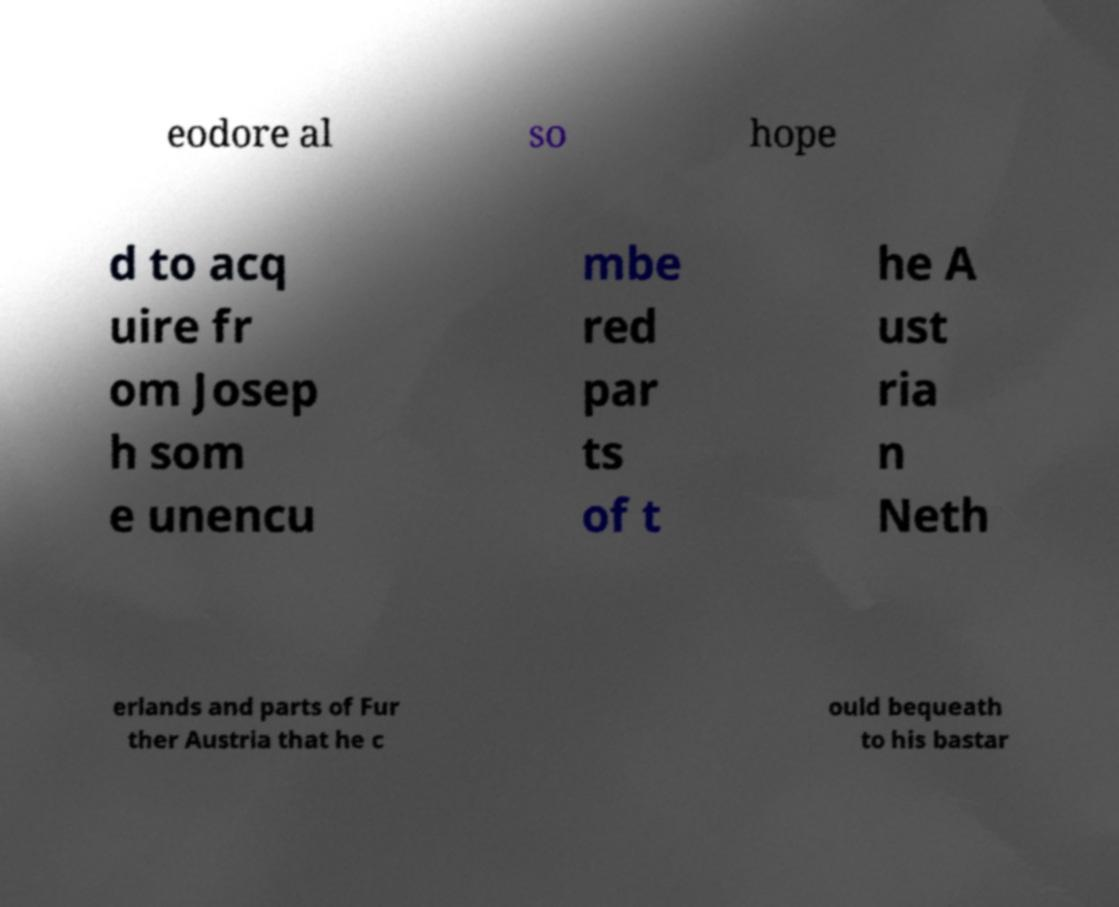Can you accurately transcribe the text from the provided image for me? eodore al so hope d to acq uire fr om Josep h som e unencu mbe red par ts of t he A ust ria n Neth erlands and parts of Fur ther Austria that he c ould bequeath to his bastar 